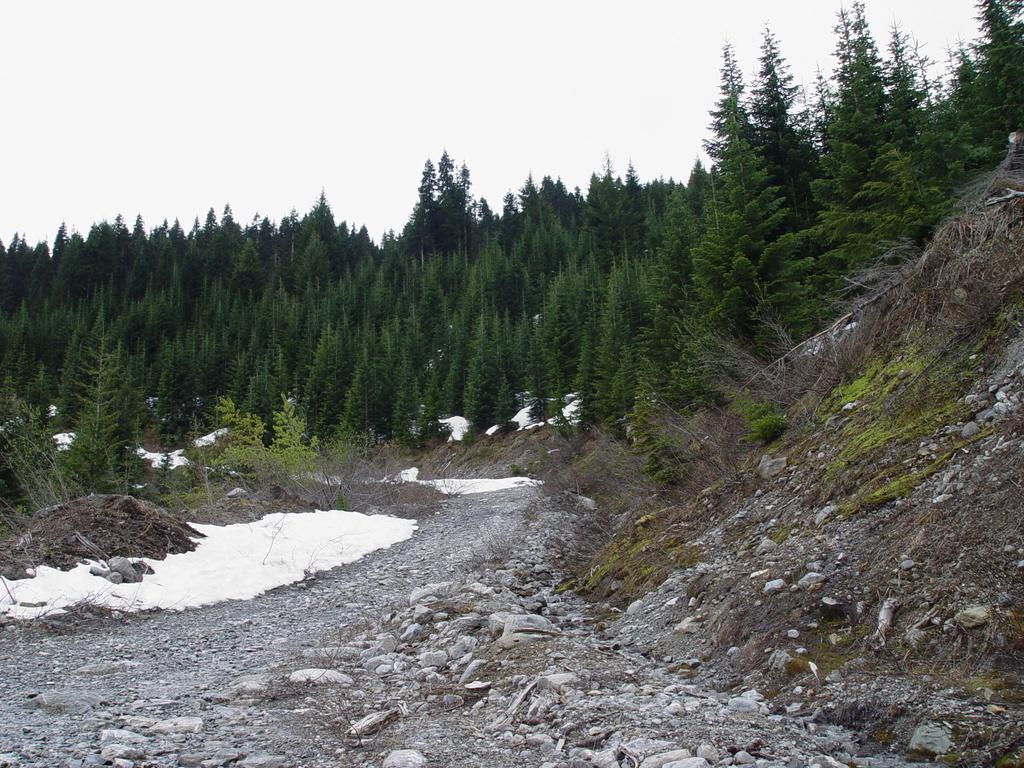What type of geographical feature is present in the image? There is a small hill in the image. What can be found near the hill? There are many stones beside the hill. What is the condition of the area on the left side of the image? The left side of the image has an area covered with snow. What can be seen in the background of the image? There is a thicket in the background of the image. How many tigers can be seen playing in the snow on the left side of the image? There are no tigers present in the image; the area on the left side is covered with snow, but no animals are visible. What type of farm animals can be seen grazing near the hill? There are no farm animals present in the image; the focus is on the hill, stones, snow, and thicket. 